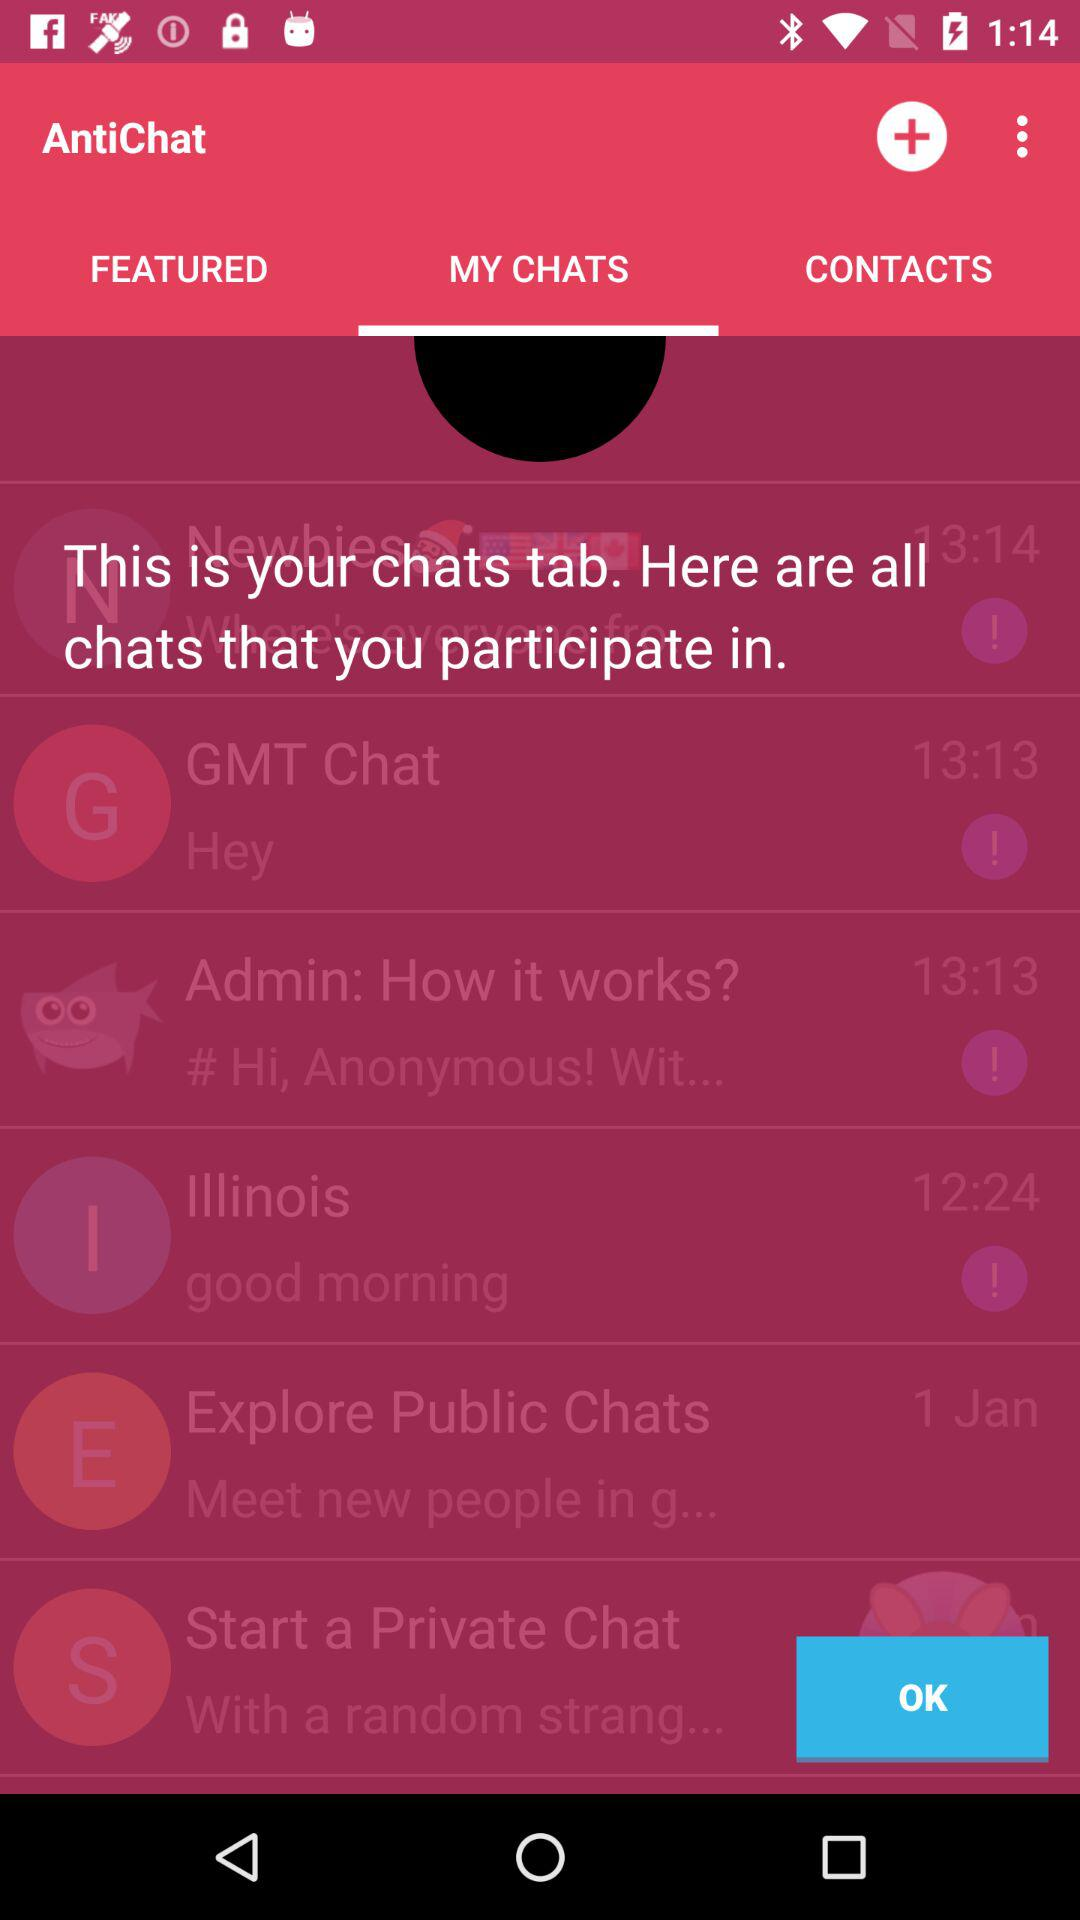Which tab is selected? The selected tab is "MY CHATS". 